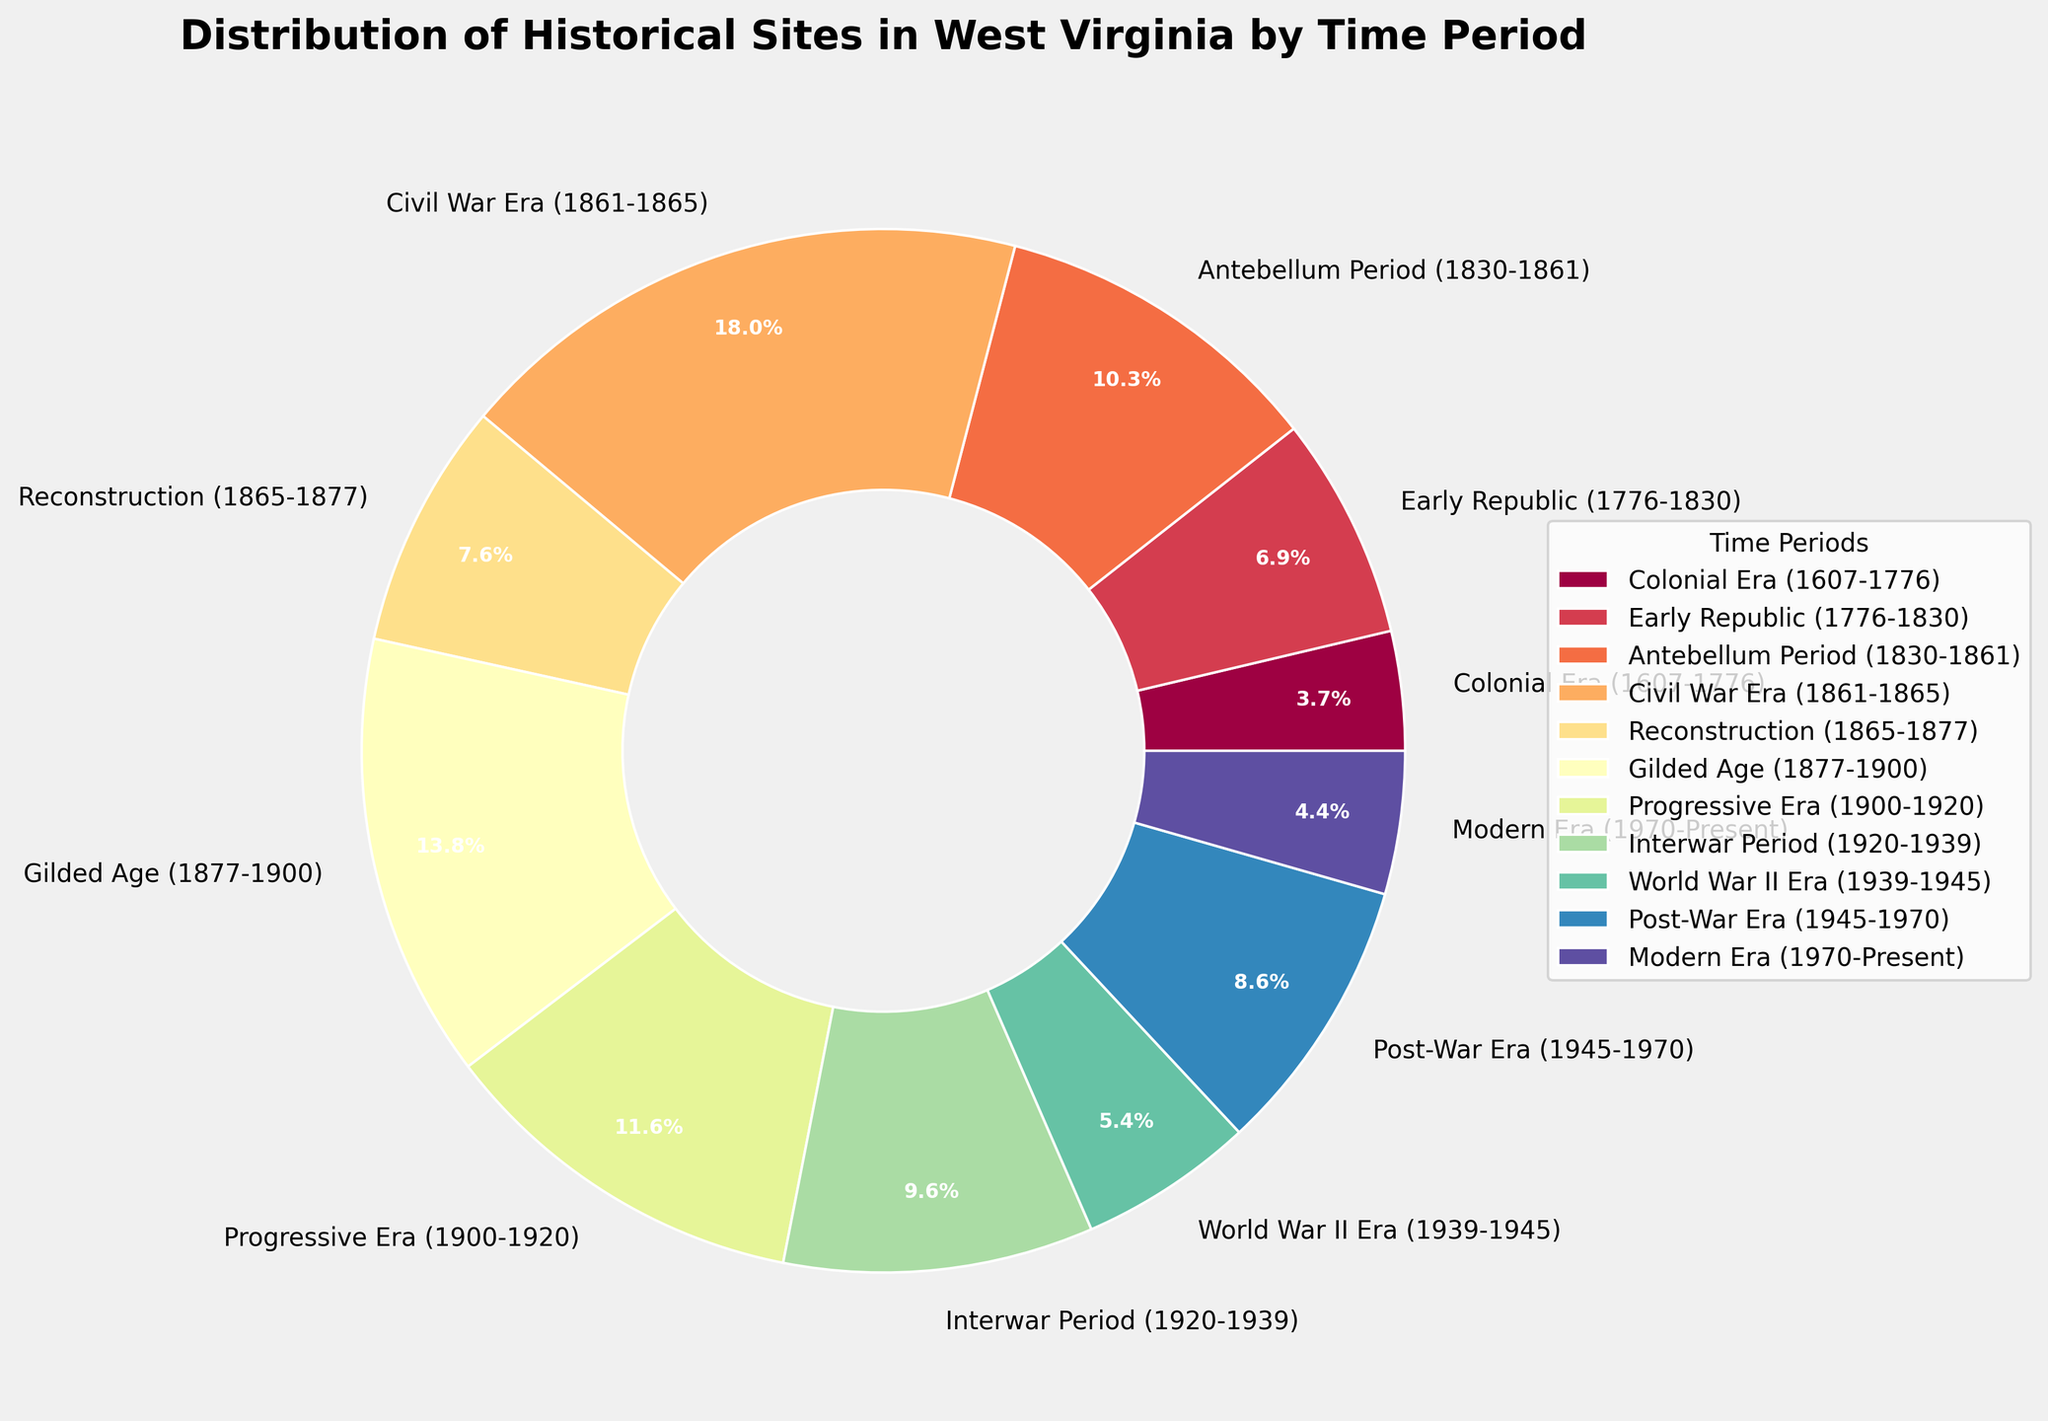What is the total number of historical sites from the Early Republic and Progressive Era? Sum the number of sites in the Early Republic (28) and the Progressive Era (47). The total is 28 + 47 = 75.
Answer: 75 Which period has a smaller number of sites: the Colonial Era or the Modern Era? Compare the number of sites in the Colonial Era (15) and the Modern Era (18). The Colonial Era has fewer sites.
Answer: Colonial Era What percentage of historical sites are from the Civil War Era? Referring to the pie chart, locate the segment corresponding to the Civil War Era. It is labeled as 25.8%.
Answer: 25.8% Do the Gilded Age and the Interwar Period together have more sites than the Civil War Era? Sum the number of sites in the Gilded Age (56) and the Interwar Period (39). Compare it to the number of sites in the Civil War Era (73). The sum is 56 + 39 = 95, which is greater than 73.
Answer: Yes Which time period has the largest slice in the pie chart? Identify the largest slice in the pie chart by their visual size and label. The Civil War Era has the largest slice.
Answer: Civil War Era Are there more historical sites from the Reconstruction period or the Post-War Era? Compare the number of sites in Reconstruction (31) and the Post-War Era (35). The Post-War Era has more sites.
Answer: Post-War Era What is the total number of historical sites in periods before the Civil War Era (1607-1861)? Add the number of sites from the Colonial Era (15), Early Republic (28), and Antebellum Period (42). The total is 15 + 28 + 42 = 85.
Answer: 85 Which period has a greater number of historical sites: the Antebellum Period or World War II Era? Compare the number of sites in the Antebellum Period (42) and World War II Era (22). The Antebellum Period has more sites.
Answer: Antebellum Period What is the sum of the number of historical sites during the Gilded Age and the Modern Era? Add the number of sites during the Gilded Age (56) and the Modern Era (18). The total is 56 + 18 = 74.
Answer: 74 